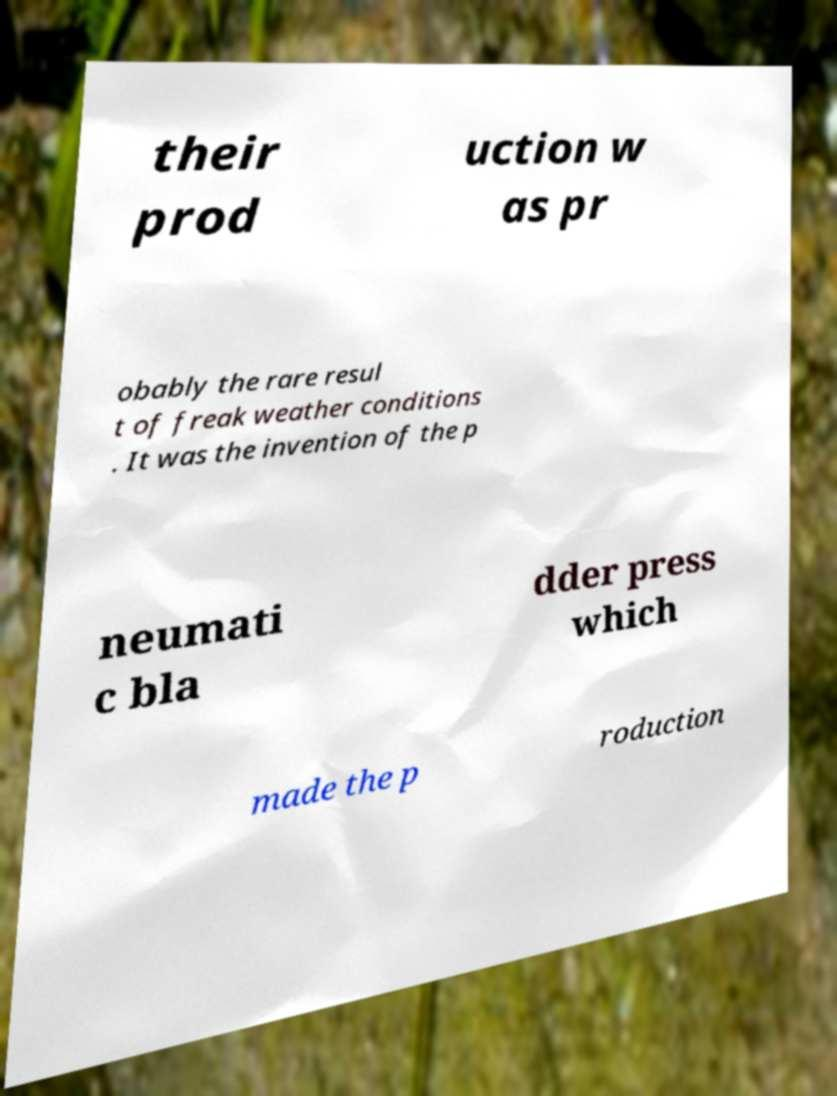What messages or text are displayed in this image? I need them in a readable, typed format. their prod uction w as pr obably the rare resul t of freak weather conditions . It was the invention of the p neumati c bla dder press which made the p roduction 